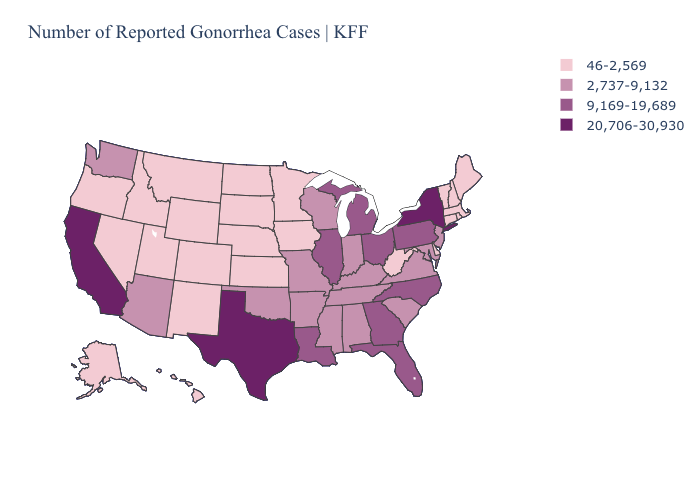Which states have the lowest value in the South?
Keep it brief. Delaware, West Virginia. Name the states that have a value in the range 2,737-9,132?
Concise answer only. Alabama, Arizona, Arkansas, Indiana, Kentucky, Maryland, Mississippi, Missouri, New Jersey, Oklahoma, South Carolina, Tennessee, Virginia, Washington, Wisconsin. What is the lowest value in states that border Nebraska?
Give a very brief answer. 46-2,569. What is the value of Connecticut?
Concise answer only. 46-2,569. Name the states that have a value in the range 20,706-30,930?
Short answer required. California, New York, Texas. What is the value of Minnesota?
Keep it brief. 46-2,569. Which states hav the highest value in the Northeast?
Be succinct. New York. Name the states that have a value in the range 9,169-19,689?
Answer briefly. Florida, Georgia, Illinois, Louisiana, Michigan, North Carolina, Ohio, Pennsylvania. Which states have the highest value in the USA?
Answer briefly. California, New York, Texas. Does Texas have the same value as California?
Answer briefly. Yes. Name the states that have a value in the range 2,737-9,132?
Keep it brief. Alabama, Arizona, Arkansas, Indiana, Kentucky, Maryland, Mississippi, Missouri, New Jersey, Oklahoma, South Carolina, Tennessee, Virginia, Washington, Wisconsin. Which states have the lowest value in the West?
Quick response, please. Alaska, Colorado, Hawaii, Idaho, Montana, Nevada, New Mexico, Oregon, Utah, Wyoming. Does Mississippi have the same value as Arizona?
Short answer required. Yes. What is the value of Pennsylvania?
Short answer required. 9,169-19,689. What is the lowest value in the West?
Quick response, please. 46-2,569. 